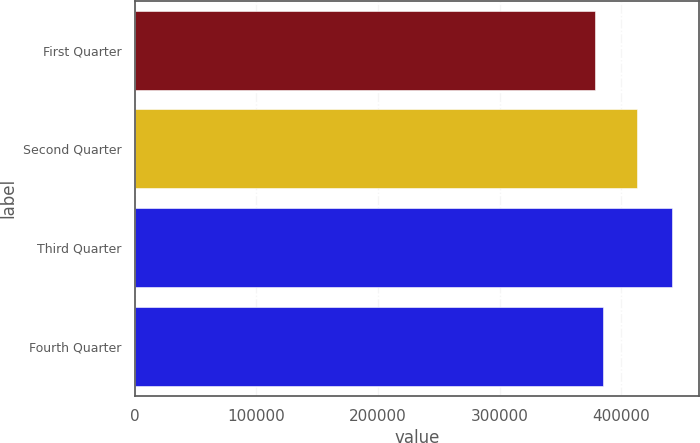<chart> <loc_0><loc_0><loc_500><loc_500><bar_chart><fcel>First Quarter<fcel>Second Quarter<fcel>Third Quarter<fcel>Fourth Quarter<nl><fcel>378304<fcel>412922<fcel>442085<fcel>384682<nl></chart> 